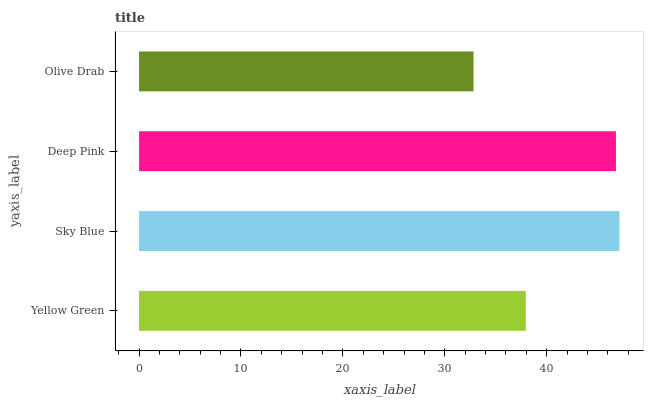Is Olive Drab the minimum?
Answer yes or no. Yes. Is Sky Blue the maximum?
Answer yes or no. Yes. Is Deep Pink the minimum?
Answer yes or no. No. Is Deep Pink the maximum?
Answer yes or no. No. Is Sky Blue greater than Deep Pink?
Answer yes or no. Yes. Is Deep Pink less than Sky Blue?
Answer yes or no. Yes. Is Deep Pink greater than Sky Blue?
Answer yes or no. No. Is Sky Blue less than Deep Pink?
Answer yes or no. No. Is Deep Pink the high median?
Answer yes or no. Yes. Is Yellow Green the low median?
Answer yes or no. Yes. Is Sky Blue the high median?
Answer yes or no. No. Is Sky Blue the low median?
Answer yes or no. No. 